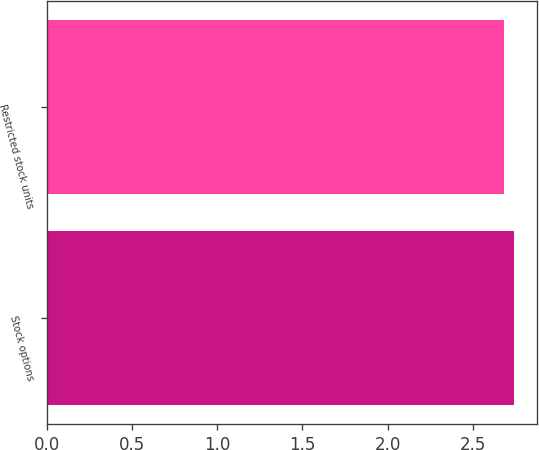<chart> <loc_0><loc_0><loc_500><loc_500><bar_chart><fcel>Stock options<fcel>Restricted stock units<nl><fcel>2.74<fcel>2.68<nl></chart> 